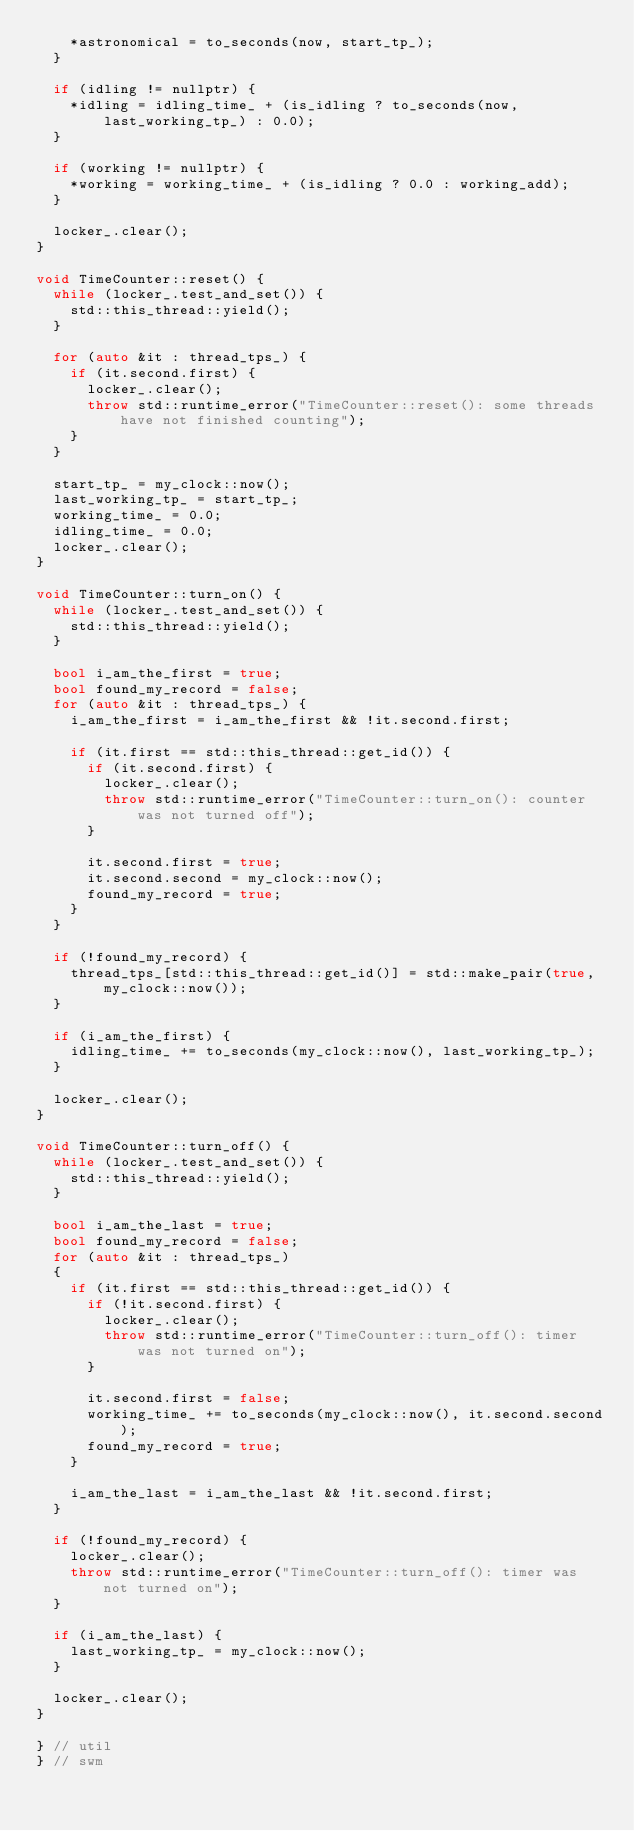<code> <loc_0><loc_0><loc_500><loc_500><_C++_>    *astronomical = to_seconds(now, start_tp_);
  }

  if (idling != nullptr) {
    *idling = idling_time_ + (is_idling ? to_seconds(now, last_working_tp_) : 0.0);
  }

  if (working != nullptr) {
    *working = working_time_ + (is_idling ? 0.0 : working_add);
  }

  locker_.clear();
}

void TimeCounter::reset() {
  while (locker_.test_and_set()) {
    std::this_thread::yield();
  }

  for (auto &it : thread_tps_) {
    if (it.second.first) {
      locker_.clear();
      throw std::runtime_error("TimeCounter::reset(): some threads have not finished counting");
    }
  }

  start_tp_ = my_clock::now();
  last_working_tp_ = start_tp_;
  working_time_ = 0.0;
  idling_time_ = 0.0;
  locker_.clear();
}

void TimeCounter::turn_on() {
  while (locker_.test_and_set()) {
    std::this_thread::yield();
  }

  bool i_am_the_first = true;
  bool found_my_record = false;
  for (auto &it : thread_tps_) {
    i_am_the_first = i_am_the_first && !it.second.first;

    if (it.first == std::this_thread::get_id()) {
      if (it.second.first) {
        locker_.clear();
        throw std::runtime_error("TimeCounter::turn_on(): counter was not turned off");
      }

      it.second.first = true;
      it.second.second = my_clock::now();
      found_my_record = true;
    }
  }

  if (!found_my_record) {
    thread_tps_[std::this_thread::get_id()] = std::make_pair(true, my_clock::now());
  }

  if (i_am_the_first) {
    idling_time_ += to_seconds(my_clock::now(), last_working_tp_);
  }

  locker_.clear();
}

void TimeCounter::turn_off() {
  while (locker_.test_and_set()) {
    std::this_thread::yield();
  }

  bool i_am_the_last = true;
  bool found_my_record = false;
  for (auto &it : thread_tps_)
  {
    if (it.first == std::this_thread::get_id()) {
      if (!it.second.first) {
        locker_.clear();
        throw std::runtime_error("TimeCounter::turn_off(): timer was not turned on");
      }

      it.second.first = false;
      working_time_ += to_seconds(my_clock::now(), it.second.second);
      found_my_record = true;
    }

    i_am_the_last = i_am_the_last && !it.second.first;
  }

  if (!found_my_record) {
    locker_.clear();
    throw std::runtime_error("TimeCounter::turn_off(): timer was not turned on");
  }

  if (i_am_the_last) {
    last_working_tp_ = my_clock::now();
  }

  locker_.clear();
}

} // util
} // swm
</code> 